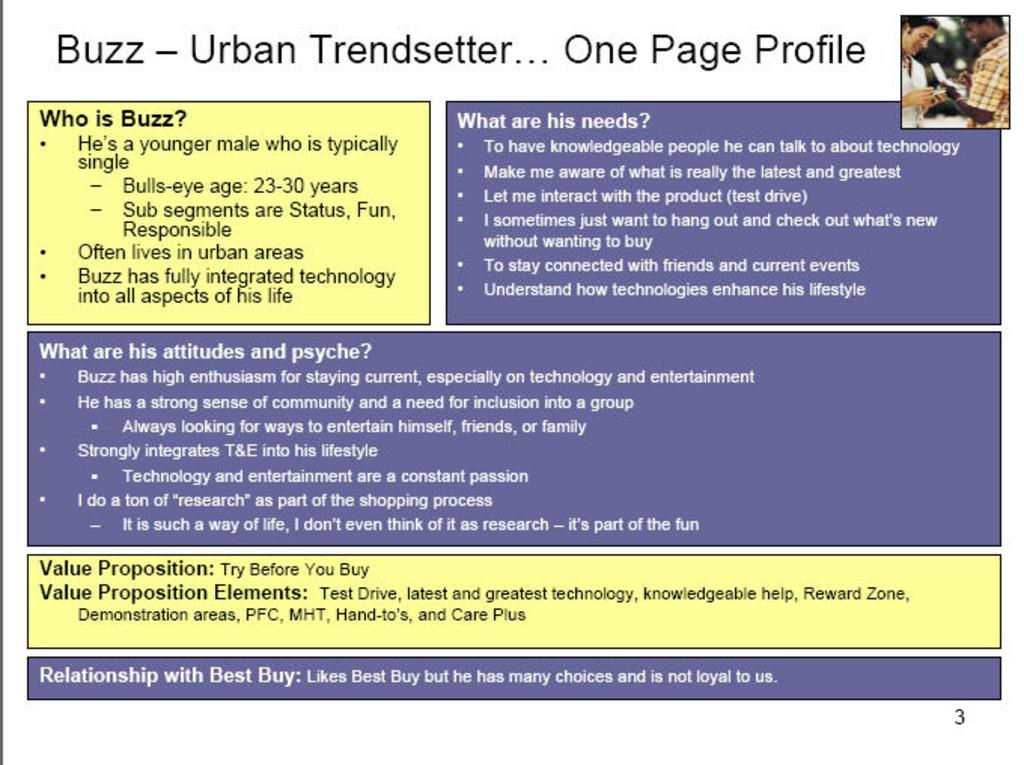What is the main subject of the image? There is an article in the image. How many people are in the image? Two people are present in the image. What are the people wearing? The people are wearing different color dresses. What are the people holding in the image? The people are holding something. What shape is the fire taking in the image? There is no fire present in the image. What decision are the people making in the image? The provided facts do not indicate that the people are making a decision in the image. 